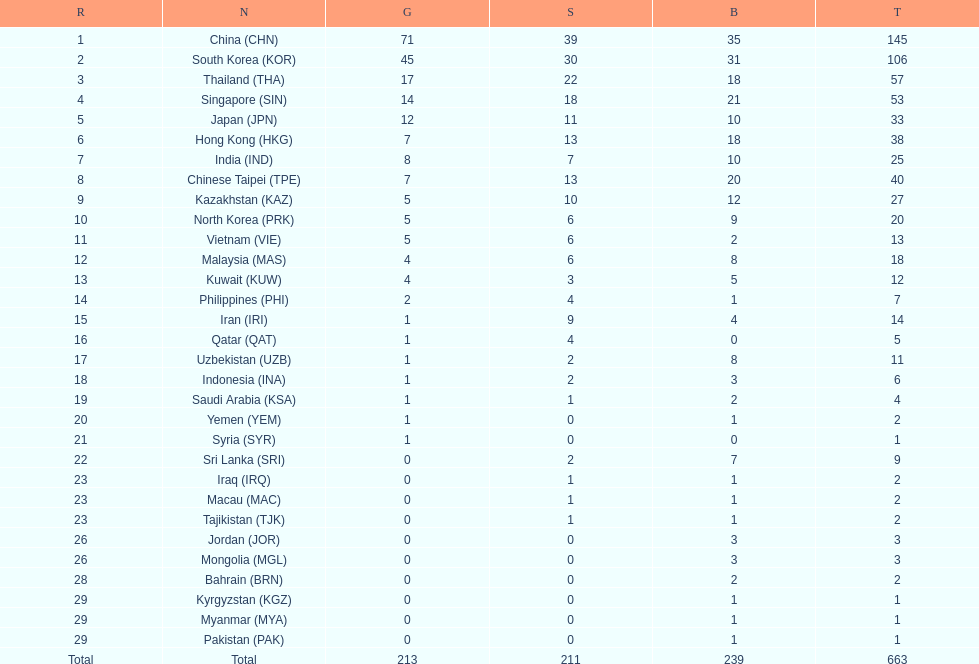What were the number of medals iran earned? 14. 